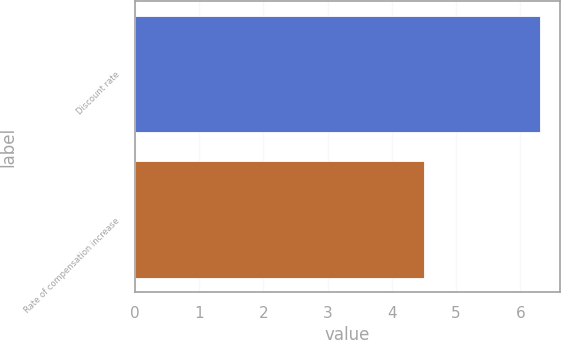Convert chart to OTSL. <chart><loc_0><loc_0><loc_500><loc_500><bar_chart><fcel>Discount rate<fcel>Rate of compensation increase<nl><fcel>6.3<fcel>4.5<nl></chart> 